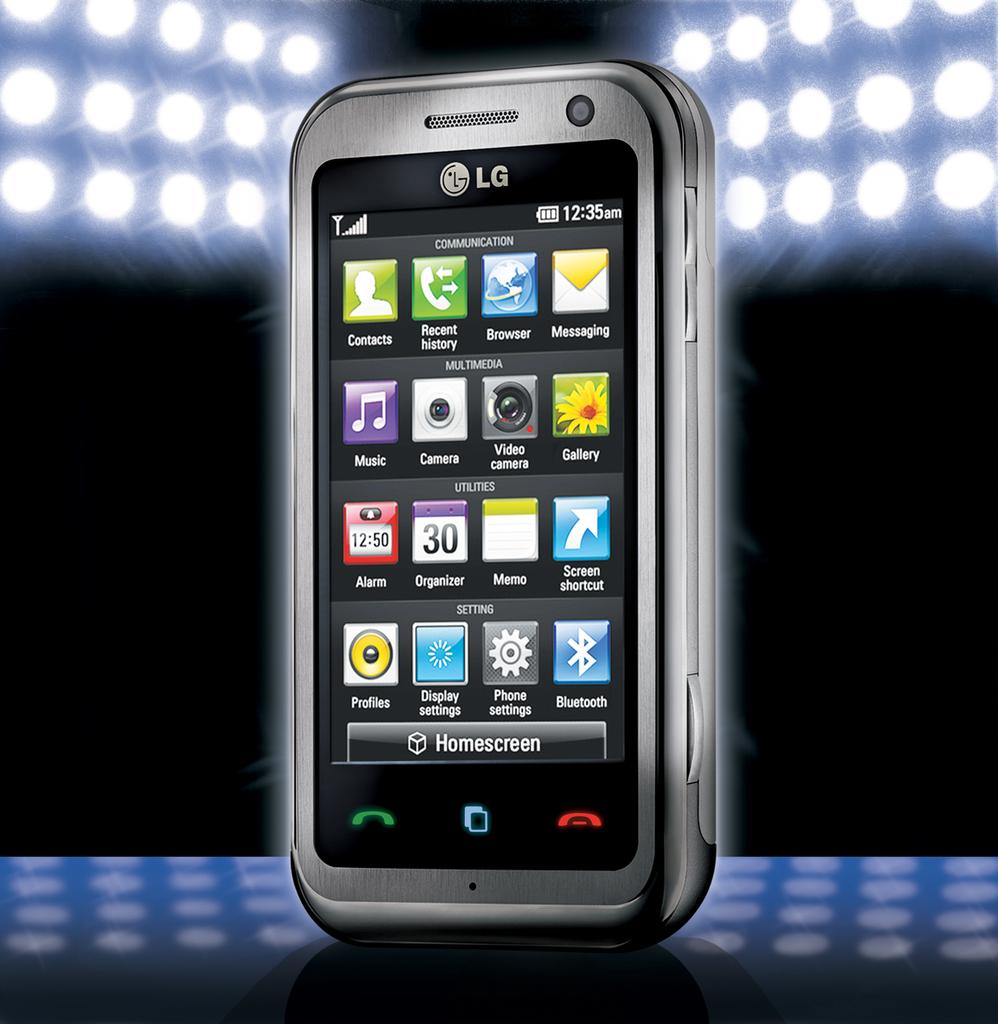What does the app on the top row, left side say?
Ensure brevity in your answer.  Contacts. 